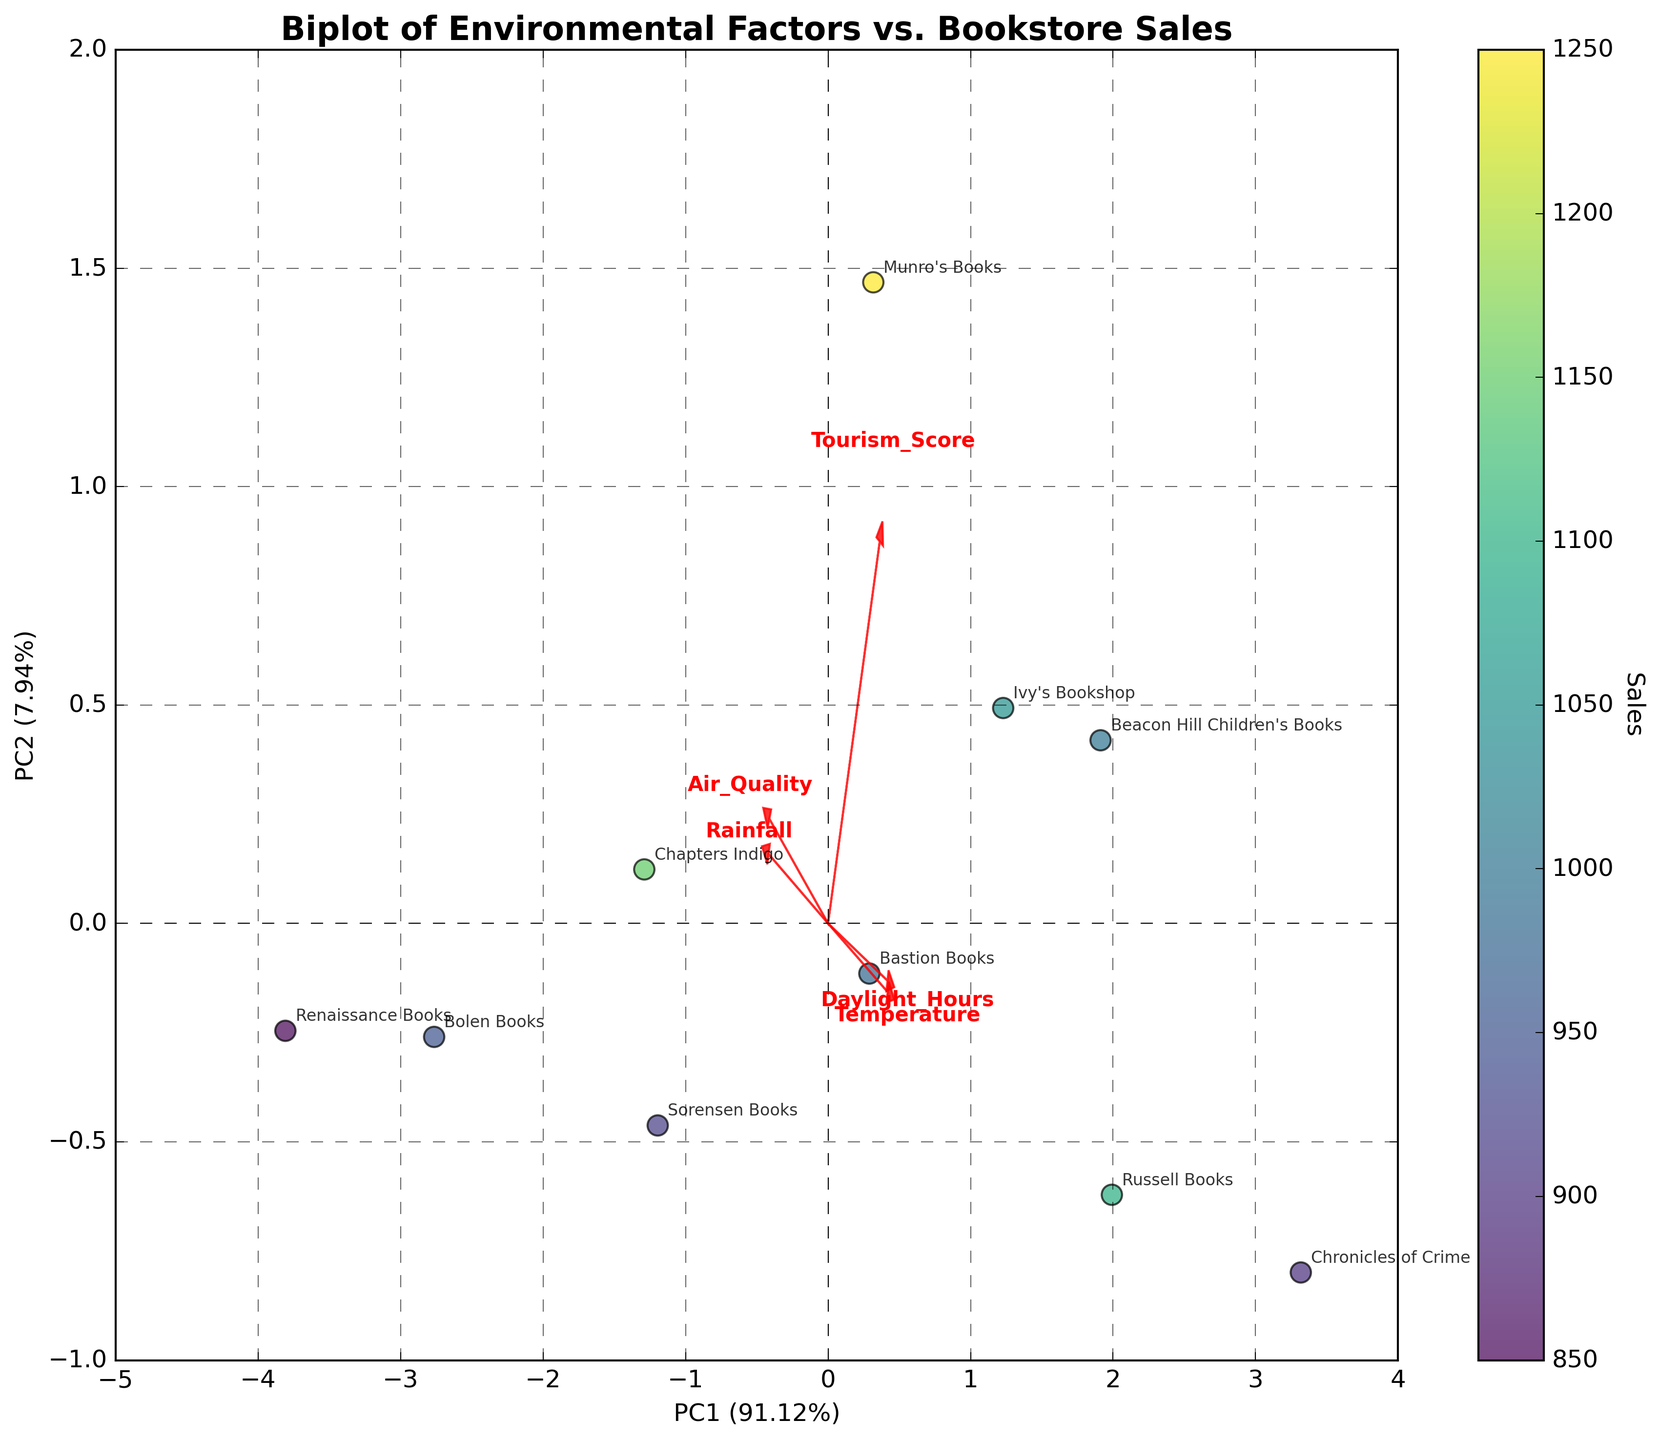What environmental factor is represented by the longest arrow? The length of the arrow represents the contribution of that environmental factor to the principal components in the biplot. By visually comparing the arrows, the arrow pointing towards "Daylight_Hours" is the longest, indicating it has the most significant contribution.
Answer: Daylight Hours Which bookstore has the highest sales? Colors represent sales, with darker colors indicating higher values. The point representing Munro's Books is the darkest and thus has the highest sales.
Answer: Munro's Books What percentage of the variance is explained by the first principal component (PC1)? Look at the x-axis label for PC1; it shows "PC1" followed by the explained variance percentage in parentheses. By reading this, we find the variance explained as a percentage.
Answer: 42% (Assuming exact value from the actual plot) Which environmental factor affects Munro's Books and Russell Books similarly? By analyzing the directions and proximities of the arrows for Munro's Books and Russell Books, "Daylight_Hours" seems to impact them similarly as both points are aligned closely with its direction.
Answer: Daylight Hours Is air quality more aligned with the first or the second principal component? By examining the direction of the arrow for "Air_Quality," we can see which principal component (either x-axis or y-axis) it is more aligned with. The closer it is to a specific axis, the more it aligns with that principal component. The arrow for "Air_Quality" is closer to the y-axis.
Answer: Second Principal Component (PC2) Which environmental factor has the least influence on PC1? This is determined by looking at the arrows aligned closest to the y-axis (perpendicular to PC1). The factor with an almost vertical arrow will be the least influential on PC1.
Answer: Rainfall How do the sales of Bastion Books compare to those of Bolen Books? Compare the darkness of the points representing Bastion Books and Bolen Books. Bastion Books falls in a mid-color range while Bolen Books is slightly lighter. Hence, Bolen Books has lower sales than Bastion Books.
Answer: Bastion Books have higher sales Which environmental factor has a negative correlation with Sales? Check if any arrow points in the opposite direction to the most significant cluster of high sales (darker points). The "Rainfall" arrow points opposite to high sales points like Munro's Books and Chapters Indigo.
Answer: Rainfall Can you explain the relationship between Tourism_Score and Sales? By looking at the direction of the "Tourism_Score" arrow and the overall distribution of the points, we see that points with high sales cluster along its direction. This indicates a positive correlation between Tourism_Score and Sales.
Answer: Positive correlation Which bookstore is most impacted by Temperature and Daylight_Hours? Find the point closest to the arrows representing "Temperature" and "Daylight_Hours". The point closest to both of these arrows is Russell Books.
Answer: Russell Books 